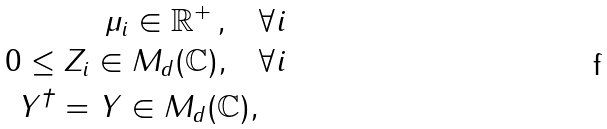Convert formula to latex. <formula><loc_0><loc_0><loc_500><loc_500>\mu _ { i } \in { \mathbb { R } } ^ { + } \, , \quad & \forall i \\ 0 \leq Z _ { i } \in M _ { d } ( { \mathbb { C } } ) , \quad & \forall i \\ Y ^ { \dag } = Y \in M _ { d } ( { \mathbb { C } } ) , &</formula> 